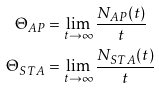Convert formula to latex. <formula><loc_0><loc_0><loc_500><loc_500>\Theta _ { A P } & = \lim _ { t \to \infty } \frac { N _ { A P } ( t ) } { t } \\ \Theta _ { S T A } & = \lim _ { t \to \infty } \frac { N _ { S T A } ( t ) } { t }</formula> 